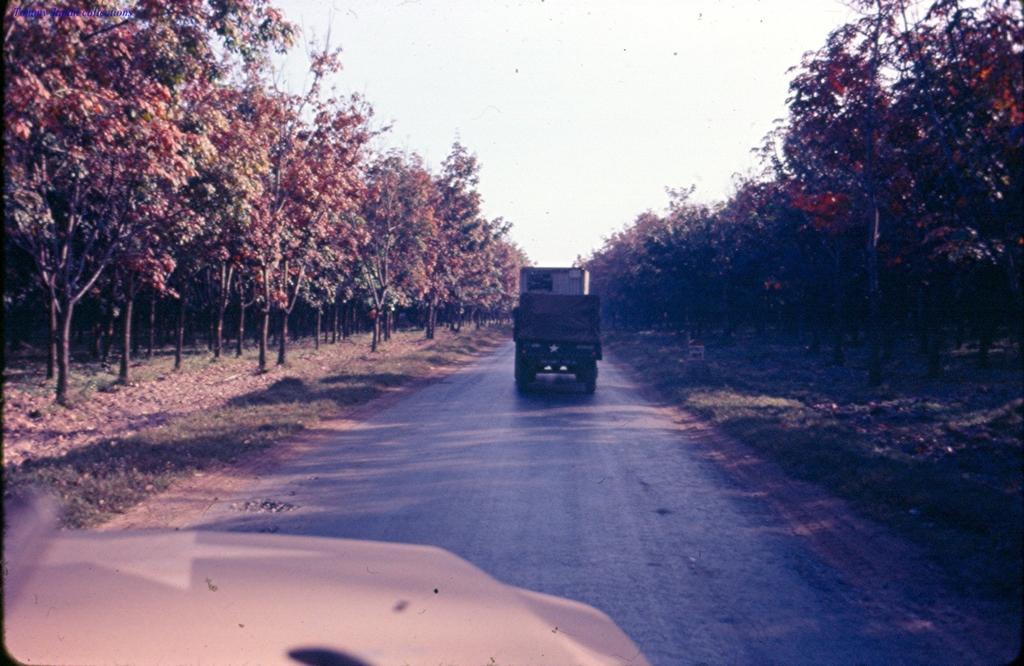Can you describe this image briefly? In this image we can see some vehicles on the road. We can also see some grass, a group of trees and the sky which looks cloudy. 